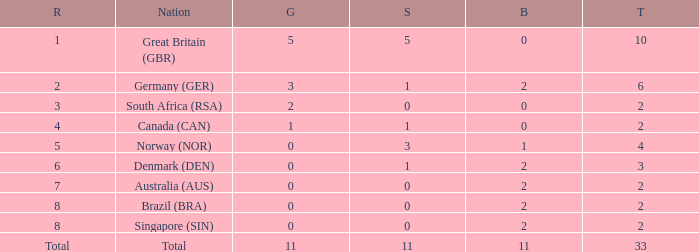What is bronze when the rank is 3 and the total is more than 2? None. Can you give me this table as a dict? {'header': ['R', 'Nation', 'G', 'S', 'B', 'T'], 'rows': [['1', 'Great Britain (GBR)', '5', '5', '0', '10'], ['2', 'Germany (GER)', '3', '1', '2', '6'], ['3', 'South Africa (RSA)', '2', '0', '0', '2'], ['4', 'Canada (CAN)', '1', '1', '0', '2'], ['5', 'Norway (NOR)', '0', '3', '1', '4'], ['6', 'Denmark (DEN)', '0', '1', '2', '3'], ['7', 'Australia (AUS)', '0', '0', '2', '2'], ['8', 'Brazil (BRA)', '0', '0', '2', '2'], ['8', 'Singapore (SIN)', '0', '0', '2', '2'], ['Total', 'Total', '11', '11', '11', '33']]} 